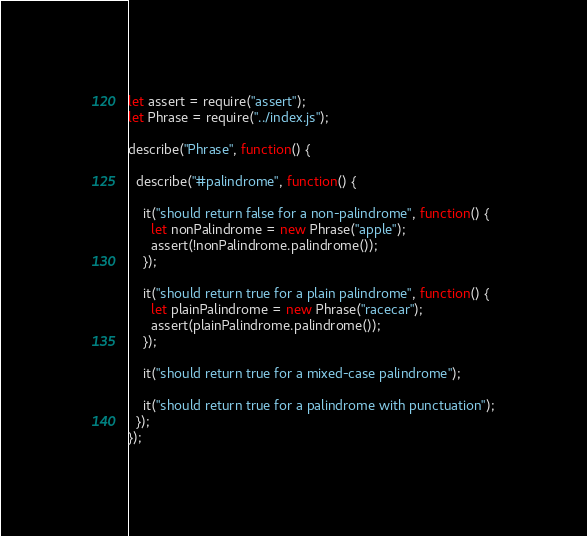<code> <loc_0><loc_0><loc_500><loc_500><_JavaScript_>let assert = require("assert");
let Phrase = require("../index.js");

describe("Phrase", function() {

  describe("#palindrome", function() {

    it("should return false for a non-palindrome", function() {
      let nonPalindrome = new Phrase("apple");
      assert(!nonPalindrome.palindrome());
    });

    it("should return true for a plain palindrome", function() {
      let plainPalindrome = new Phrase("racecar");
      assert(plainPalindrome.palindrome());
    });

    it("should return true for a mixed-case palindrome");

    it("should return true for a palindrome with punctuation");
  });
});
</code> 